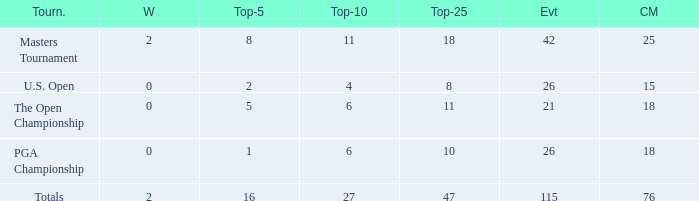When the wins are less than 0 and the Top-5 1 what is the average cuts? None. 